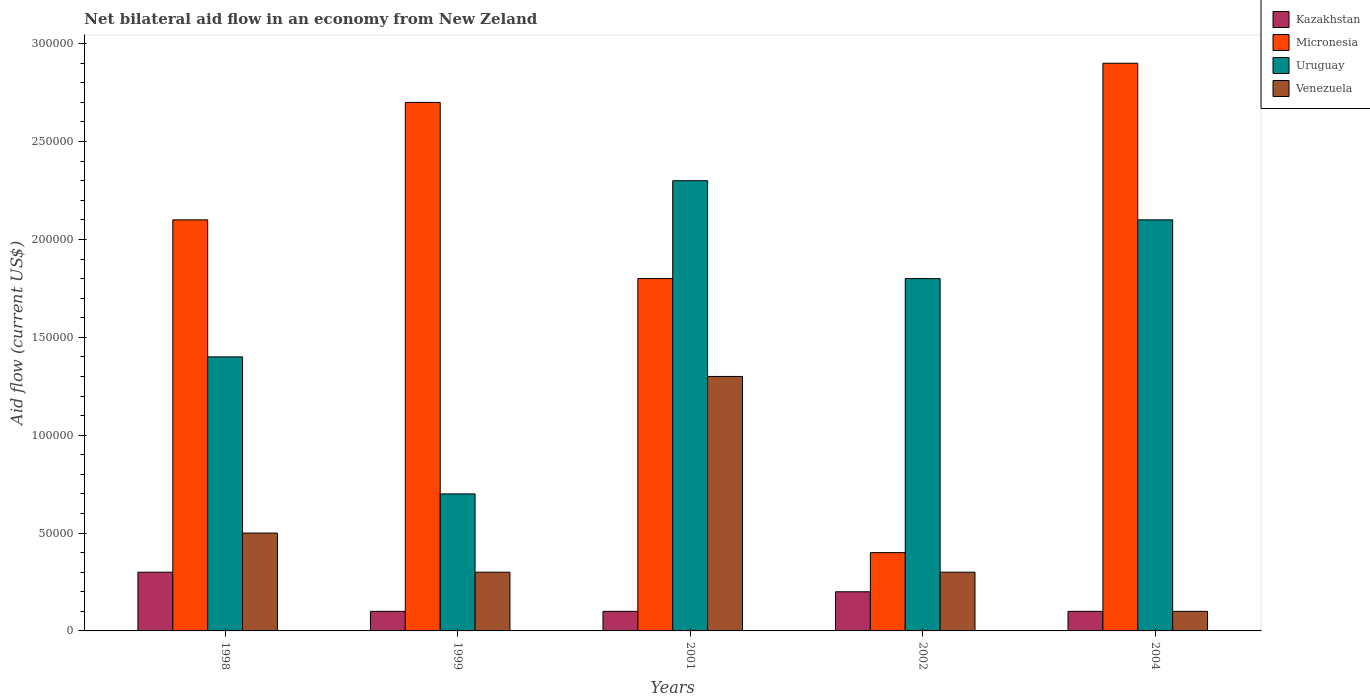How many different coloured bars are there?
Your answer should be compact. 4. Are the number of bars on each tick of the X-axis equal?
Ensure brevity in your answer.  Yes. How many bars are there on the 1st tick from the left?
Make the answer very short. 4. How many bars are there on the 3rd tick from the right?
Ensure brevity in your answer.  4. What is the label of the 1st group of bars from the left?
Keep it short and to the point. 1998. In how many cases, is the number of bars for a given year not equal to the number of legend labels?
Offer a very short reply. 0. Across all years, what is the maximum net bilateral aid flow in Venezuela?
Offer a very short reply. 1.30e+05. In which year was the net bilateral aid flow in Kazakhstan minimum?
Offer a terse response. 1999. What is the total net bilateral aid flow in Venezuela in the graph?
Ensure brevity in your answer.  2.50e+05. What is the average net bilateral aid flow in Uruguay per year?
Offer a very short reply. 1.66e+05. In the year 2004, what is the difference between the net bilateral aid flow in Kazakhstan and net bilateral aid flow in Micronesia?
Offer a terse response. -2.80e+05. In how many years, is the net bilateral aid flow in Kazakhstan greater than 280000 US$?
Offer a terse response. 0. What is the difference between the highest and the lowest net bilateral aid flow in Uruguay?
Your answer should be compact. 1.60e+05. Is the sum of the net bilateral aid flow in Kazakhstan in 1998 and 2004 greater than the maximum net bilateral aid flow in Venezuela across all years?
Your answer should be compact. No. What does the 1st bar from the left in 2001 represents?
Your response must be concise. Kazakhstan. What does the 3rd bar from the right in 2002 represents?
Give a very brief answer. Micronesia. Is it the case that in every year, the sum of the net bilateral aid flow in Uruguay and net bilateral aid flow in Venezuela is greater than the net bilateral aid flow in Kazakhstan?
Keep it short and to the point. Yes. How many bars are there?
Your response must be concise. 20. How many years are there in the graph?
Provide a short and direct response. 5. What is the difference between two consecutive major ticks on the Y-axis?
Your response must be concise. 5.00e+04. Are the values on the major ticks of Y-axis written in scientific E-notation?
Keep it short and to the point. No. Does the graph contain grids?
Your answer should be compact. No. What is the title of the graph?
Provide a succinct answer. Net bilateral aid flow in an economy from New Zeland. Does "Nicaragua" appear as one of the legend labels in the graph?
Offer a very short reply. No. What is the label or title of the X-axis?
Keep it short and to the point. Years. What is the Aid flow (current US$) of Kazakhstan in 1998?
Give a very brief answer. 3.00e+04. What is the Aid flow (current US$) in Uruguay in 1998?
Keep it short and to the point. 1.40e+05. What is the Aid flow (current US$) of Venezuela in 1998?
Keep it short and to the point. 5.00e+04. What is the Aid flow (current US$) in Kazakhstan in 1999?
Your answer should be very brief. 10000. What is the Aid flow (current US$) of Uruguay in 1999?
Your response must be concise. 7.00e+04. What is the Aid flow (current US$) of Kazakhstan in 2001?
Provide a short and direct response. 10000. What is the Aid flow (current US$) in Micronesia in 2001?
Give a very brief answer. 1.80e+05. What is the Aid flow (current US$) of Venezuela in 2001?
Ensure brevity in your answer.  1.30e+05. What is the Aid flow (current US$) in Venezuela in 2002?
Ensure brevity in your answer.  3.00e+04. What is the Aid flow (current US$) in Uruguay in 2004?
Provide a succinct answer. 2.10e+05. Across all years, what is the maximum Aid flow (current US$) of Micronesia?
Provide a succinct answer. 2.90e+05. Across all years, what is the minimum Aid flow (current US$) in Micronesia?
Offer a terse response. 4.00e+04. Across all years, what is the minimum Aid flow (current US$) of Uruguay?
Make the answer very short. 7.00e+04. Across all years, what is the minimum Aid flow (current US$) of Venezuela?
Make the answer very short. 10000. What is the total Aid flow (current US$) in Kazakhstan in the graph?
Make the answer very short. 8.00e+04. What is the total Aid flow (current US$) in Micronesia in the graph?
Your response must be concise. 9.90e+05. What is the total Aid flow (current US$) of Uruguay in the graph?
Keep it short and to the point. 8.30e+05. What is the total Aid flow (current US$) in Venezuela in the graph?
Ensure brevity in your answer.  2.50e+05. What is the difference between the Aid flow (current US$) in Micronesia in 1998 and that in 1999?
Keep it short and to the point. -6.00e+04. What is the difference between the Aid flow (current US$) in Uruguay in 1998 and that in 1999?
Your answer should be very brief. 7.00e+04. What is the difference between the Aid flow (current US$) in Venezuela in 1998 and that in 1999?
Your response must be concise. 2.00e+04. What is the difference between the Aid flow (current US$) of Kazakhstan in 1998 and that in 2001?
Give a very brief answer. 2.00e+04. What is the difference between the Aid flow (current US$) in Kazakhstan in 1998 and that in 2002?
Your answer should be compact. 10000. What is the difference between the Aid flow (current US$) of Uruguay in 1998 and that in 2002?
Keep it short and to the point. -4.00e+04. What is the difference between the Aid flow (current US$) of Venezuela in 1998 and that in 2002?
Provide a succinct answer. 2.00e+04. What is the difference between the Aid flow (current US$) in Kazakhstan in 1998 and that in 2004?
Provide a short and direct response. 2.00e+04. What is the difference between the Aid flow (current US$) in Uruguay in 1998 and that in 2004?
Make the answer very short. -7.00e+04. What is the difference between the Aid flow (current US$) of Venezuela in 1998 and that in 2004?
Offer a very short reply. 4.00e+04. What is the difference between the Aid flow (current US$) in Kazakhstan in 1999 and that in 2001?
Your answer should be very brief. 0. What is the difference between the Aid flow (current US$) of Venezuela in 1999 and that in 2001?
Your response must be concise. -1.00e+05. What is the difference between the Aid flow (current US$) of Kazakhstan in 1999 and that in 2002?
Your response must be concise. -10000. What is the difference between the Aid flow (current US$) in Uruguay in 1999 and that in 2004?
Provide a short and direct response. -1.40e+05. What is the difference between the Aid flow (current US$) of Venezuela in 1999 and that in 2004?
Offer a very short reply. 2.00e+04. What is the difference between the Aid flow (current US$) in Kazakhstan in 2001 and that in 2002?
Provide a succinct answer. -10000. What is the difference between the Aid flow (current US$) in Micronesia in 2001 and that in 2002?
Ensure brevity in your answer.  1.40e+05. What is the difference between the Aid flow (current US$) of Uruguay in 2001 and that in 2002?
Offer a terse response. 5.00e+04. What is the difference between the Aid flow (current US$) of Kazakhstan in 2001 and that in 2004?
Offer a terse response. 0. What is the difference between the Aid flow (current US$) of Uruguay in 2001 and that in 2004?
Provide a succinct answer. 2.00e+04. What is the difference between the Aid flow (current US$) in Venezuela in 2001 and that in 2004?
Make the answer very short. 1.20e+05. What is the difference between the Aid flow (current US$) of Venezuela in 2002 and that in 2004?
Your response must be concise. 2.00e+04. What is the difference between the Aid flow (current US$) of Kazakhstan in 1998 and the Aid flow (current US$) of Venezuela in 1999?
Give a very brief answer. 0. What is the difference between the Aid flow (current US$) in Micronesia in 1998 and the Aid flow (current US$) in Venezuela in 1999?
Your response must be concise. 1.80e+05. What is the difference between the Aid flow (current US$) of Uruguay in 1998 and the Aid flow (current US$) of Venezuela in 1999?
Provide a succinct answer. 1.10e+05. What is the difference between the Aid flow (current US$) in Kazakhstan in 1998 and the Aid flow (current US$) in Micronesia in 2001?
Give a very brief answer. -1.50e+05. What is the difference between the Aid flow (current US$) of Kazakhstan in 1998 and the Aid flow (current US$) of Venezuela in 2001?
Your answer should be very brief. -1.00e+05. What is the difference between the Aid flow (current US$) of Uruguay in 1998 and the Aid flow (current US$) of Venezuela in 2001?
Your answer should be compact. 10000. What is the difference between the Aid flow (current US$) of Kazakhstan in 1998 and the Aid flow (current US$) of Uruguay in 2002?
Give a very brief answer. -1.50e+05. What is the difference between the Aid flow (current US$) in Kazakhstan in 1998 and the Aid flow (current US$) in Venezuela in 2002?
Your answer should be compact. 0. What is the difference between the Aid flow (current US$) of Micronesia in 1998 and the Aid flow (current US$) of Uruguay in 2004?
Provide a succinct answer. 0. What is the difference between the Aid flow (current US$) of Kazakhstan in 1999 and the Aid flow (current US$) of Micronesia in 2001?
Your response must be concise. -1.70e+05. What is the difference between the Aid flow (current US$) of Kazakhstan in 1999 and the Aid flow (current US$) of Uruguay in 2001?
Keep it short and to the point. -2.20e+05. What is the difference between the Aid flow (current US$) in Kazakhstan in 1999 and the Aid flow (current US$) in Venezuela in 2001?
Keep it short and to the point. -1.20e+05. What is the difference between the Aid flow (current US$) in Micronesia in 1999 and the Aid flow (current US$) in Uruguay in 2001?
Keep it short and to the point. 4.00e+04. What is the difference between the Aid flow (current US$) in Micronesia in 1999 and the Aid flow (current US$) in Venezuela in 2001?
Your answer should be compact. 1.40e+05. What is the difference between the Aid flow (current US$) in Uruguay in 1999 and the Aid flow (current US$) in Venezuela in 2001?
Provide a short and direct response. -6.00e+04. What is the difference between the Aid flow (current US$) of Kazakhstan in 1999 and the Aid flow (current US$) of Micronesia in 2002?
Give a very brief answer. -3.00e+04. What is the difference between the Aid flow (current US$) of Kazakhstan in 1999 and the Aid flow (current US$) of Venezuela in 2002?
Your response must be concise. -2.00e+04. What is the difference between the Aid flow (current US$) of Micronesia in 1999 and the Aid flow (current US$) of Uruguay in 2002?
Give a very brief answer. 9.00e+04. What is the difference between the Aid flow (current US$) of Kazakhstan in 1999 and the Aid flow (current US$) of Micronesia in 2004?
Your answer should be compact. -2.80e+05. What is the difference between the Aid flow (current US$) in Kazakhstan in 1999 and the Aid flow (current US$) in Uruguay in 2004?
Ensure brevity in your answer.  -2.00e+05. What is the difference between the Aid flow (current US$) of Micronesia in 1999 and the Aid flow (current US$) of Uruguay in 2004?
Ensure brevity in your answer.  6.00e+04. What is the difference between the Aid flow (current US$) of Uruguay in 1999 and the Aid flow (current US$) of Venezuela in 2004?
Offer a terse response. 6.00e+04. What is the difference between the Aid flow (current US$) of Kazakhstan in 2001 and the Aid flow (current US$) of Micronesia in 2002?
Your answer should be compact. -3.00e+04. What is the difference between the Aid flow (current US$) in Kazakhstan in 2001 and the Aid flow (current US$) in Venezuela in 2002?
Provide a short and direct response. -2.00e+04. What is the difference between the Aid flow (current US$) of Kazakhstan in 2001 and the Aid flow (current US$) of Micronesia in 2004?
Keep it short and to the point. -2.80e+05. What is the difference between the Aid flow (current US$) in Kazakhstan in 2001 and the Aid flow (current US$) in Uruguay in 2004?
Keep it short and to the point. -2.00e+05. What is the difference between the Aid flow (current US$) of Micronesia in 2001 and the Aid flow (current US$) of Uruguay in 2004?
Make the answer very short. -3.00e+04. What is the difference between the Aid flow (current US$) of Micronesia in 2001 and the Aid flow (current US$) of Venezuela in 2004?
Give a very brief answer. 1.70e+05. What is the difference between the Aid flow (current US$) of Uruguay in 2001 and the Aid flow (current US$) of Venezuela in 2004?
Provide a short and direct response. 2.20e+05. What is the difference between the Aid flow (current US$) in Kazakhstan in 2002 and the Aid flow (current US$) in Micronesia in 2004?
Provide a short and direct response. -2.70e+05. What is the difference between the Aid flow (current US$) in Kazakhstan in 2002 and the Aid flow (current US$) in Uruguay in 2004?
Give a very brief answer. -1.90e+05. What is the difference between the Aid flow (current US$) in Kazakhstan in 2002 and the Aid flow (current US$) in Venezuela in 2004?
Your response must be concise. 10000. What is the difference between the Aid flow (current US$) of Micronesia in 2002 and the Aid flow (current US$) of Uruguay in 2004?
Your response must be concise. -1.70e+05. What is the average Aid flow (current US$) in Kazakhstan per year?
Keep it short and to the point. 1.60e+04. What is the average Aid flow (current US$) of Micronesia per year?
Ensure brevity in your answer.  1.98e+05. What is the average Aid flow (current US$) of Uruguay per year?
Offer a very short reply. 1.66e+05. What is the average Aid flow (current US$) of Venezuela per year?
Give a very brief answer. 5.00e+04. In the year 1998, what is the difference between the Aid flow (current US$) in Kazakhstan and Aid flow (current US$) in Uruguay?
Your answer should be very brief. -1.10e+05. In the year 1998, what is the difference between the Aid flow (current US$) of Kazakhstan and Aid flow (current US$) of Venezuela?
Your response must be concise. -2.00e+04. In the year 1998, what is the difference between the Aid flow (current US$) of Micronesia and Aid flow (current US$) of Uruguay?
Make the answer very short. 7.00e+04. In the year 1999, what is the difference between the Aid flow (current US$) of Kazakhstan and Aid flow (current US$) of Uruguay?
Your response must be concise. -6.00e+04. In the year 1999, what is the difference between the Aid flow (current US$) in Kazakhstan and Aid flow (current US$) in Venezuela?
Provide a succinct answer. -2.00e+04. In the year 1999, what is the difference between the Aid flow (current US$) in Uruguay and Aid flow (current US$) in Venezuela?
Offer a very short reply. 4.00e+04. In the year 2001, what is the difference between the Aid flow (current US$) of Kazakhstan and Aid flow (current US$) of Micronesia?
Offer a very short reply. -1.70e+05. In the year 2001, what is the difference between the Aid flow (current US$) of Kazakhstan and Aid flow (current US$) of Uruguay?
Your response must be concise. -2.20e+05. In the year 2001, what is the difference between the Aid flow (current US$) of Kazakhstan and Aid flow (current US$) of Venezuela?
Your response must be concise. -1.20e+05. In the year 2001, what is the difference between the Aid flow (current US$) of Micronesia and Aid flow (current US$) of Uruguay?
Keep it short and to the point. -5.00e+04. In the year 2001, what is the difference between the Aid flow (current US$) of Uruguay and Aid flow (current US$) of Venezuela?
Give a very brief answer. 1.00e+05. In the year 2002, what is the difference between the Aid flow (current US$) in Kazakhstan and Aid flow (current US$) in Micronesia?
Provide a short and direct response. -2.00e+04. In the year 2002, what is the difference between the Aid flow (current US$) of Kazakhstan and Aid flow (current US$) of Uruguay?
Make the answer very short. -1.60e+05. In the year 2002, what is the difference between the Aid flow (current US$) of Micronesia and Aid flow (current US$) of Uruguay?
Offer a terse response. -1.40e+05. In the year 2002, what is the difference between the Aid flow (current US$) of Micronesia and Aid flow (current US$) of Venezuela?
Keep it short and to the point. 10000. In the year 2002, what is the difference between the Aid flow (current US$) of Uruguay and Aid flow (current US$) of Venezuela?
Provide a short and direct response. 1.50e+05. In the year 2004, what is the difference between the Aid flow (current US$) of Kazakhstan and Aid flow (current US$) of Micronesia?
Your response must be concise. -2.80e+05. In the year 2004, what is the difference between the Aid flow (current US$) of Kazakhstan and Aid flow (current US$) of Uruguay?
Your answer should be very brief. -2.00e+05. In the year 2004, what is the difference between the Aid flow (current US$) in Kazakhstan and Aid flow (current US$) in Venezuela?
Provide a succinct answer. 0. In the year 2004, what is the difference between the Aid flow (current US$) in Micronesia and Aid flow (current US$) in Uruguay?
Your response must be concise. 8.00e+04. In the year 2004, what is the difference between the Aid flow (current US$) in Micronesia and Aid flow (current US$) in Venezuela?
Provide a short and direct response. 2.80e+05. In the year 2004, what is the difference between the Aid flow (current US$) of Uruguay and Aid flow (current US$) of Venezuela?
Give a very brief answer. 2.00e+05. What is the ratio of the Aid flow (current US$) of Micronesia in 1998 to that in 1999?
Provide a short and direct response. 0.78. What is the ratio of the Aid flow (current US$) of Uruguay in 1998 to that in 1999?
Offer a terse response. 2. What is the ratio of the Aid flow (current US$) of Kazakhstan in 1998 to that in 2001?
Ensure brevity in your answer.  3. What is the ratio of the Aid flow (current US$) of Uruguay in 1998 to that in 2001?
Ensure brevity in your answer.  0.61. What is the ratio of the Aid flow (current US$) of Venezuela in 1998 to that in 2001?
Give a very brief answer. 0.38. What is the ratio of the Aid flow (current US$) in Micronesia in 1998 to that in 2002?
Ensure brevity in your answer.  5.25. What is the ratio of the Aid flow (current US$) in Uruguay in 1998 to that in 2002?
Keep it short and to the point. 0.78. What is the ratio of the Aid flow (current US$) of Venezuela in 1998 to that in 2002?
Your response must be concise. 1.67. What is the ratio of the Aid flow (current US$) in Micronesia in 1998 to that in 2004?
Your answer should be compact. 0.72. What is the ratio of the Aid flow (current US$) of Uruguay in 1998 to that in 2004?
Offer a terse response. 0.67. What is the ratio of the Aid flow (current US$) of Kazakhstan in 1999 to that in 2001?
Keep it short and to the point. 1. What is the ratio of the Aid flow (current US$) in Micronesia in 1999 to that in 2001?
Make the answer very short. 1.5. What is the ratio of the Aid flow (current US$) of Uruguay in 1999 to that in 2001?
Provide a succinct answer. 0.3. What is the ratio of the Aid flow (current US$) of Venezuela in 1999 to that in 2001?
Your response must be concise. 0.23. What is the ratio of the Aid flow (current US$) in Kazakhstan in 1999 to that in 2002?
Give a very brief answer. 0.5. What is the ratio of the Aid flow (current US$) in Micronesia in 1999 to that in 2002?
Ensure brevity in your answer.  6.75. What is the ratio of the Aid flow (current US$) in Uruguay in 1999 to that in 2002?
Give a very brief answer. 0.39. What is the ratio of the Aid flow (current US$) of Micronesia in 1999 to that in 2004?
Give a very brief answer. 0.93. What is the ratio of the Aid flow (current US$) in Uruguay in 1999 to that in 2004?
Give a very brief answer. 0.33. What is the ratio of the Aid flow (current US$) of Kazakhstan in 2001 to that in 2002?
Offer a very short reply. 0.5. What is the ratio of the Aid flow (current US$) in Micronesia in 2001 to that in 2002?
Your answer should be compact. 4.5. What is the ratio of the Aid flow (current US$) in Uruguay in 2001 to that in 2002?
Your answer should be very brief. 1.28. What is the ratio of the Aid flow (current US$) of Venezuela in 2001 to that in 2002?
Keep it short and to the point. 4.33. What is the ratio of the Aid flow (current US$) in Micronesia in 2001 to that in 2004?
Offer a terse response. 0.62. What is the ratio of the Aid flow (current US$) in Uruguay in 2001 to that in 2004?
Your answer should be very brief. 1.1. What is the ratio of the Aid flow (current US$) in Micronesia in 2002 to that in 2004?
Your answer should be compact. 0.14. What is the ratio of the Aid flow (current US$) in Venezuela in 2002 to that in 2004?
Your answer should be very brief. 3. What is the difference between the highest and the second highest Aid flow (current US$) in Kazakhstan?
Keep it short and to the point. 10000. What is the difference between the highest and the second highest Aid flow (current US$) of Uruguay?
Provide a succinct answer. 2.00e+04. What is the difference between the highest and the lowest Aid flow (current US$) in Kazakhstan?
Your answer should be compact. 2.00e+04. What is the difference between the highest and the lowest Aid flow (current US$) of Uruguay?
Make the answer very short. 1.60e+05. 